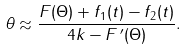Convert formula to latex. <formula><loc_0><loc_0><loc_500><loc_500>\theta \approx \frac { F ( \Theta ) + f _ { 1 } ( t ) - f _ { 2 } ( t ) } { 4 k - F ^ { \, \prime } ( \Theta ) } .</formula> 